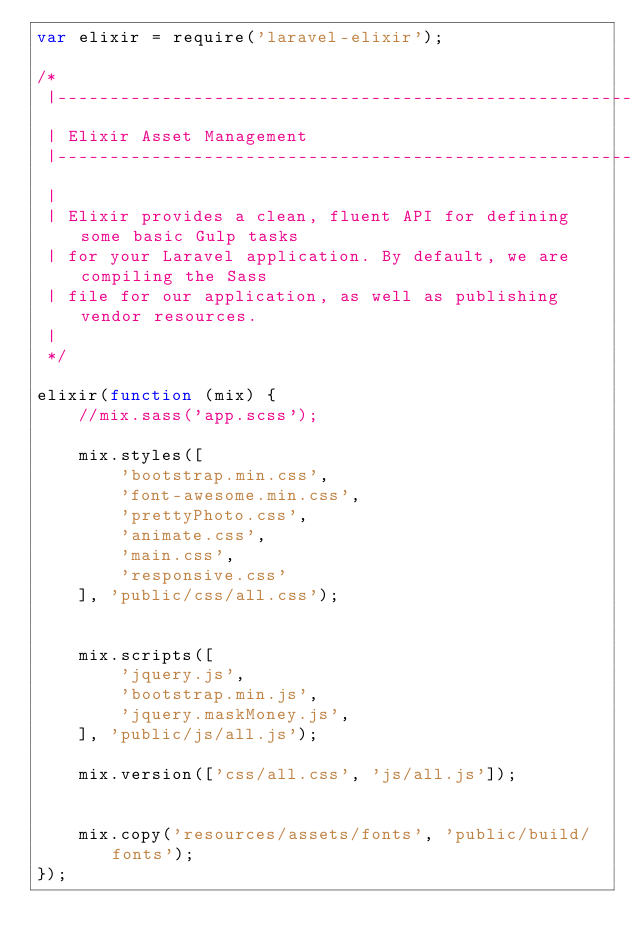<code> <loc_0><loc_0><loc_500><loc_500><_JavaScript_>var elixir = require('laravel-elixir');

/*
 |--------------------------------------------------------------------------
 | Elixir Asset Management
 |--------------------------------------------------------------------------
 |
 | Elixir provides a clean, fluent API for defining some basic Gulp tasks
 | for your Laravel application. By default, we are compiling the Sass
 | file for our application, as well as publishing vendor resources.
 |
 */

elixir(function (mix) {
    //mix.sass('app.scss');

    mix.styles([
        'bootstrap.min.css',
        'font-awesome.min.css',
        'prettyPhoto.css',
        'animate.css',
        'main.css',
        'responsive.css'
    ], 'public/css/all.css');


    mix.scripts([
        'jquery.js',
        'bootstrap.min.js',      
        'jquery.maskMoney.js',
    ], 'public/js/all.js');

    mix.version(['css/all.css', 'js/all.js']);

    
    mix.copy('resources/assets/fonts', 'public/build/fonts');
});
</code> 